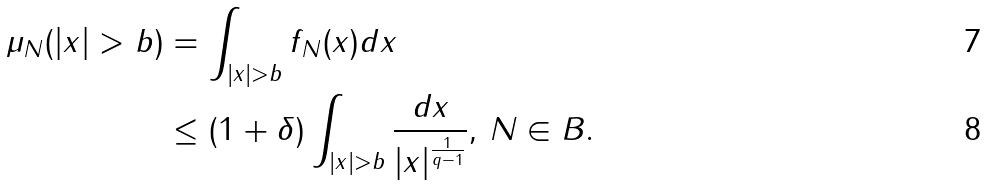<formula> <loc_0><loc_0><loc_500><loc_500>\mu _ { N } ( | x | > b ) & = \int _ { | x | > b } f _ { N } ( x ) d x \\ & \leq { ( 1 + \delta ) } \int _ { | x | > b } \frac { d x } { | x | ^ { \frac { 1 } { q - 1 } } } , \, N \in B .</formula> 